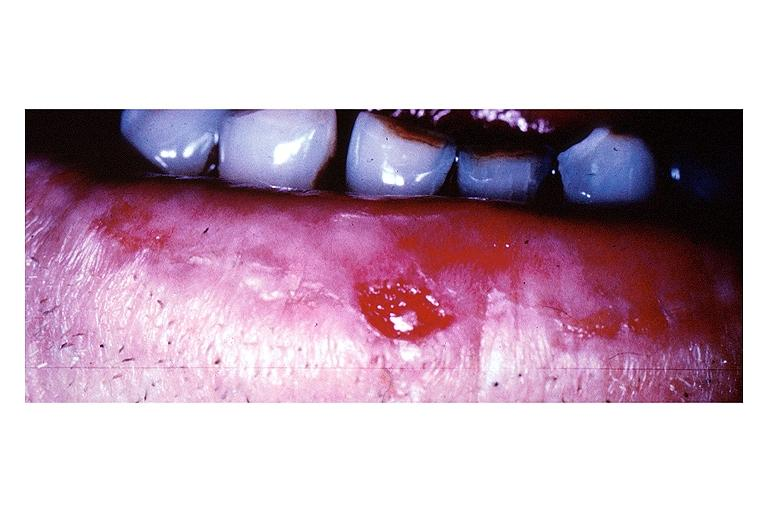s oral present?
Answer the question using a single word or phrase. Yes 